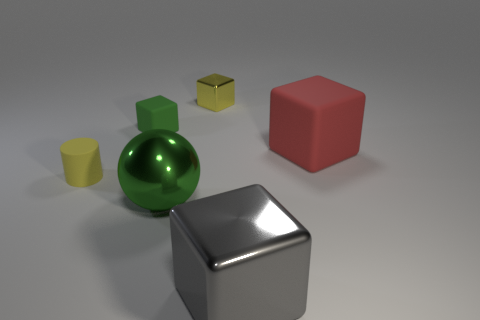Add 3 brown matte objects. How many objects exist? 9 Subtract all gray shiny cubes. How many cubes are left? 3 Subtract all green cubes. How many cubes are left? 3 Subtract all spheres. How many objects are left? 5 Subtract 1 cubes. How many cubes are left? 3 Subtract all brown blocks. Subtract all green cylinders. How many blocks are left? 4 Subtract all cyan cylinders. How many gray cubes are left? 1 Subtract all green balls. Subtract all gray shiny blocks. How many objects are left? 4 Add 1 gray metal things. How many gray metal things are left? 2 Add 5 small brown metal blocks. How many small brown metal blocks exist? 5 